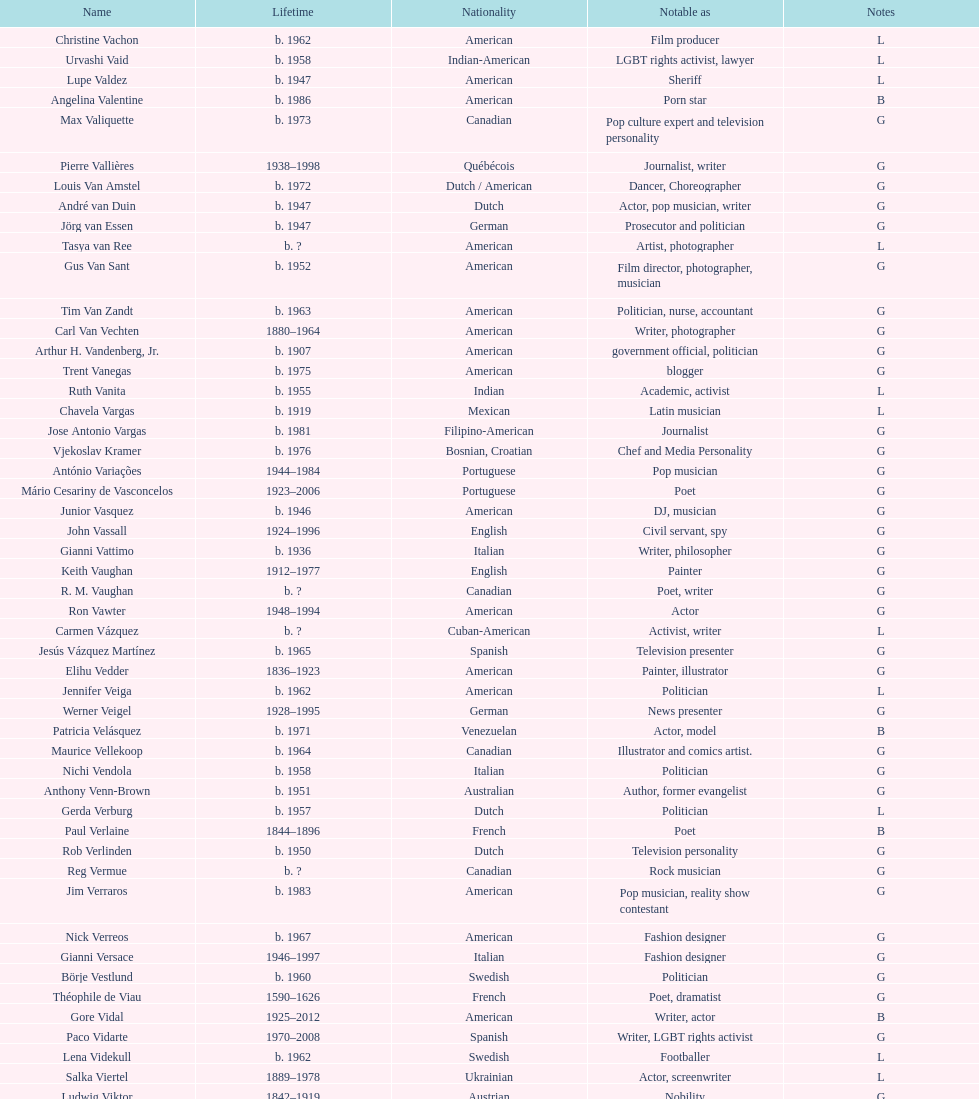What is the gap in birth years between vachon and vaid? 4 years. 